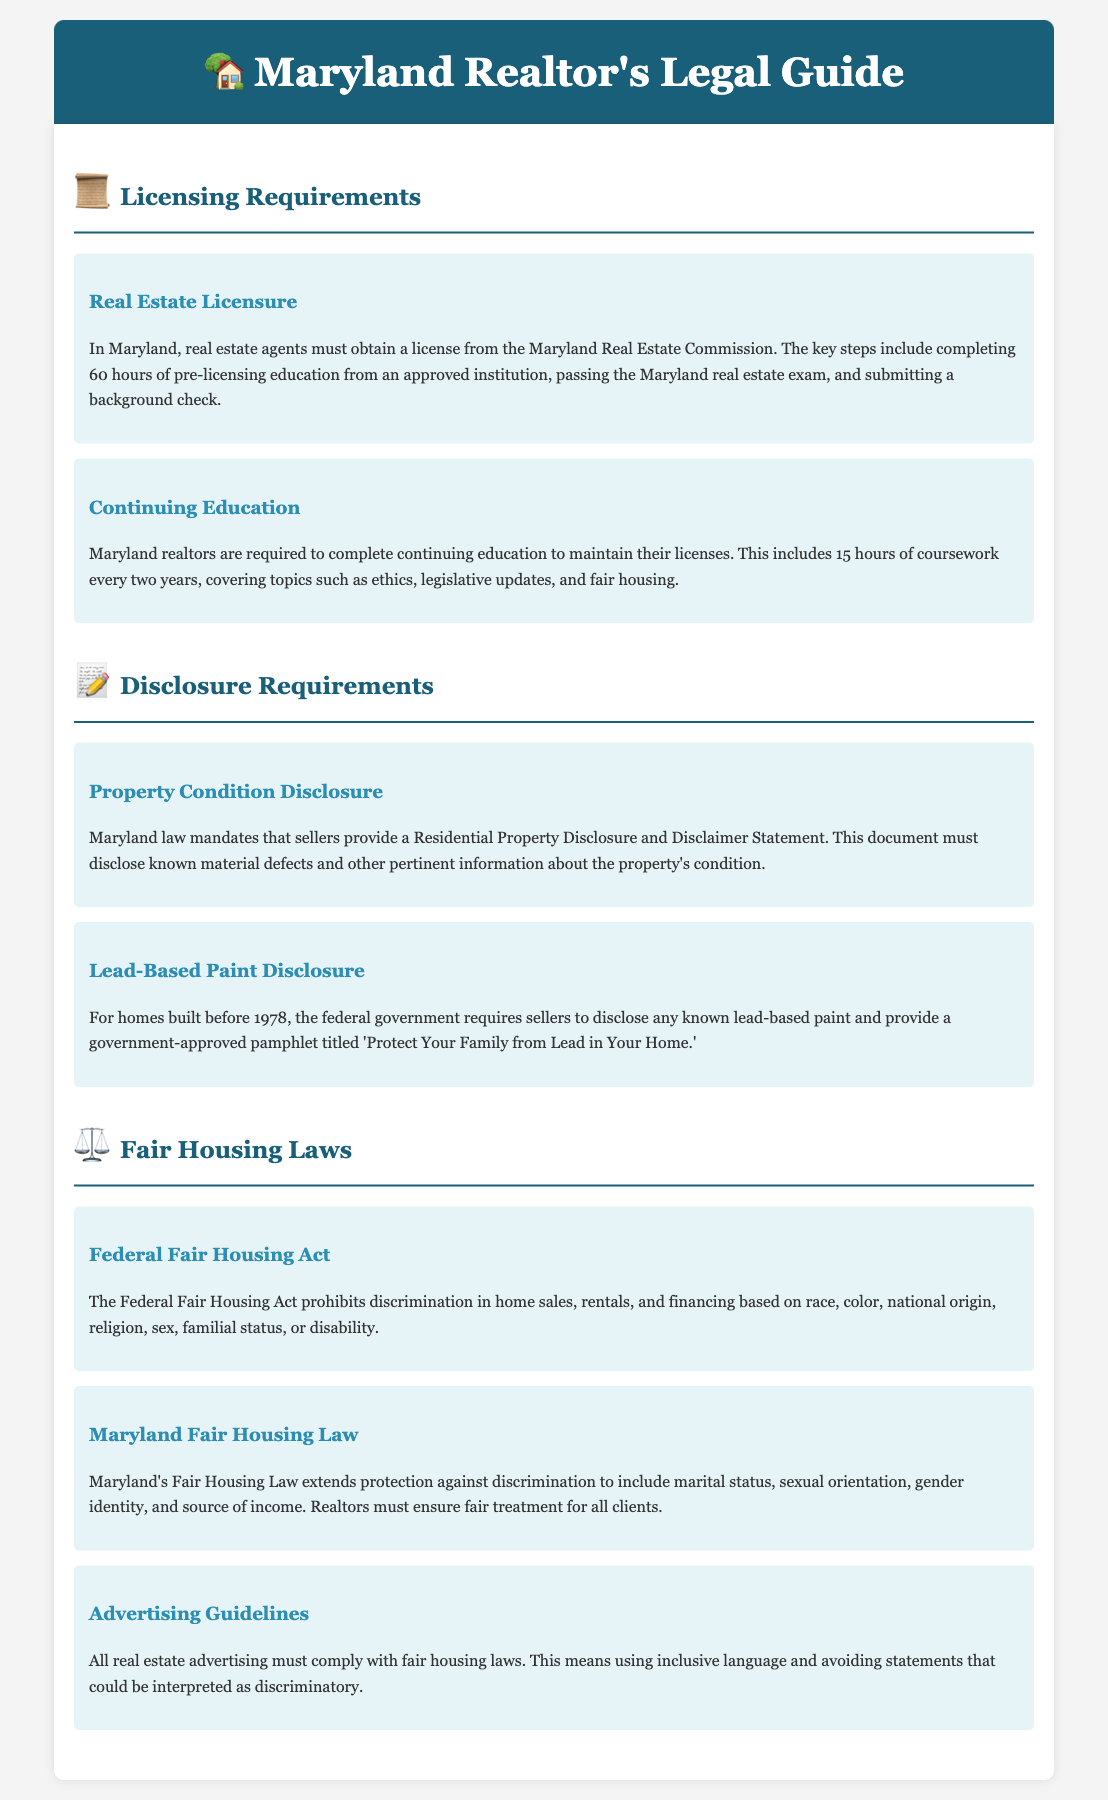what is the required pre-licensing education hours for real estate agents in Maryland? Real estate agents in Maryland must complete 60 hours of pre-licensing education from an approved institution.
Answer: 60 hours how many hours of continuing education are required every two years? Maryland realtors are required to complete 15 hours of coursework every two years.
Answer: 15 hours what document must sellers provide regarding property condition? Sellers must provide a Residential Property Disclosure and Disclaimer Statement.
Answer: Residential Property Disclosure and Disclaimer Statement which year is significant for lead-based paint disclosure requirements? The federal government requires disclosure for homes built before 1978.
Answer: 1978 what additional statuses are protected under Maryland's Fair Housing Law? Maryland's Fair Housing Law includes marital status, sexual orientation, gender identity, and source of income.
Answer: marital status, sexual orientation, gender identity, and source of income what does the Federal Fair Housing Act prohibit? The Federal Fair Housing Act prohibits discrimination in home sales, rentals, and financing.
Answer: discrimination how often must realtors complete continuing education? Realtors must complete continuing education every two years.
Answer: every two years what language must all real estate advertising comply with? All real estate advertising must comply with fair housing laws.
Answer: fair housing laws 